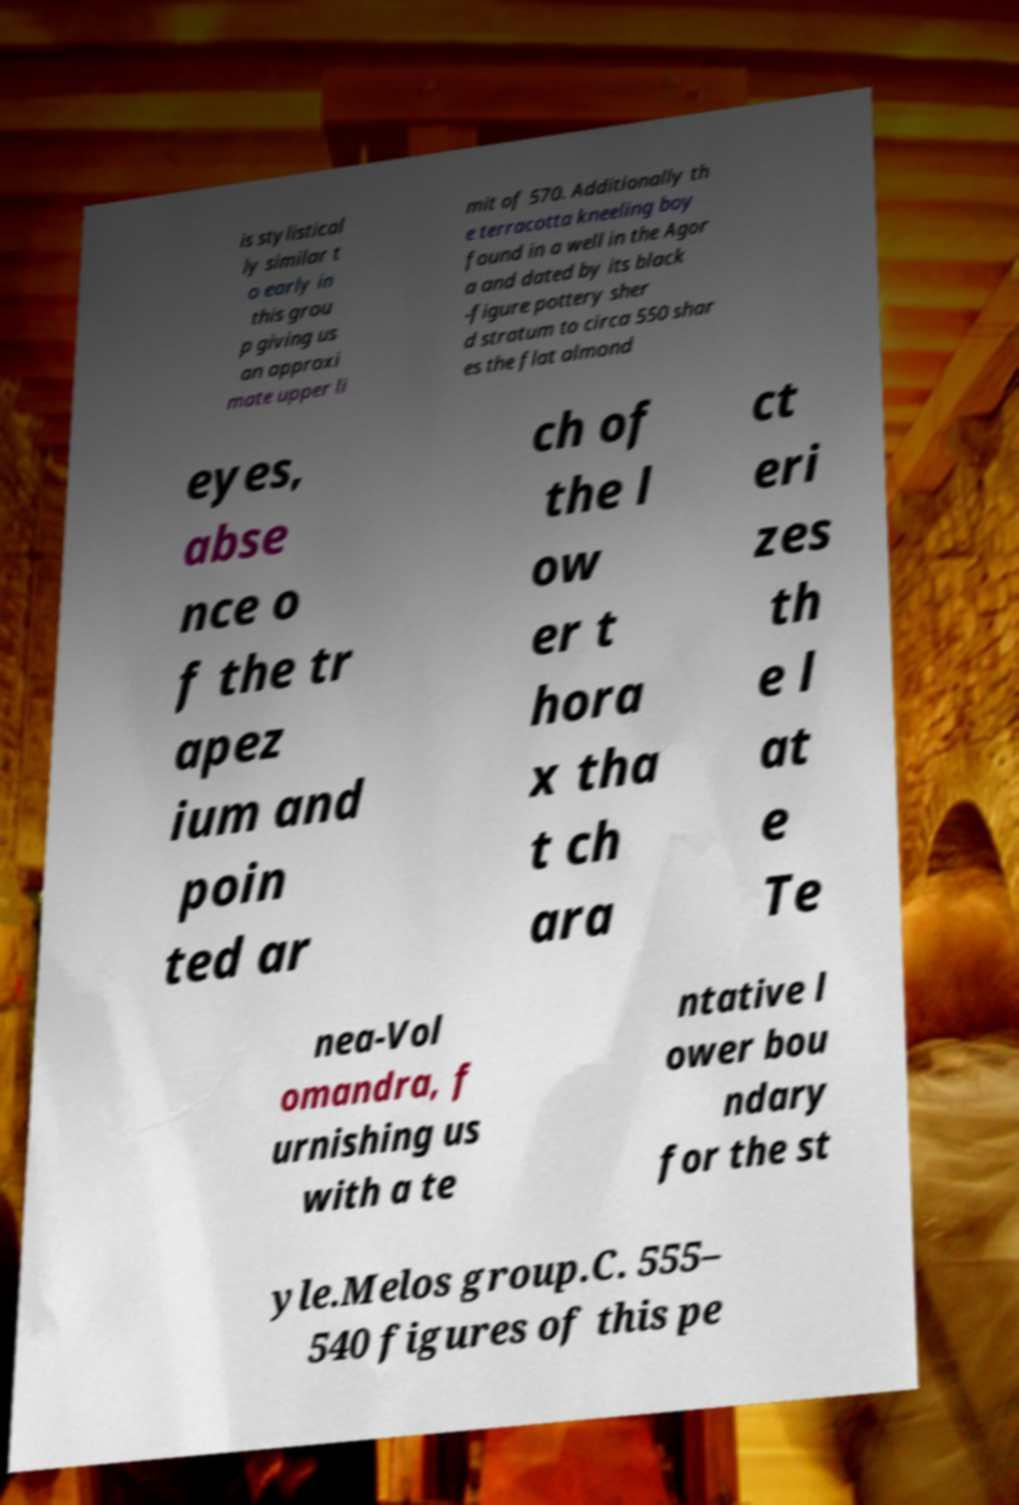I need the written content from this picture converted into text. Can you do that? is stylistical ly similar t o early in this grou p giving us an approxi mate upper li mit of 570. Additionally th e terracotta kneeling boy found in a well in the Agor a and dated by its black -figure pottery sher d stratum to circa 550 shar es the flat almond eyes, abse nce o f the tr apez ium and poin ted ar ch of the l ow er t hora x tha t ch ara ct eri zes th e l at e Te nea-Vol omandra, f urnishing us with a te ntative l ower bou ndary for the st yle.Melos group.C. 555– 540 figures of this pe 